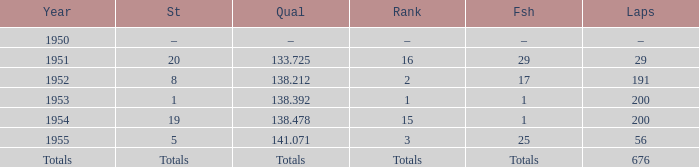What ranking that had a start of 19? 15.0. 